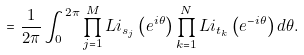<formula> <loc_0><loc_0><loc_500><loc_500>= \frac { 1 } { 2 \pi } \int _ { 0 } ^ { 2 \pi } \prod _ { j = 1 } ^ { M } L i _ { s _ { j } } \left ( e ^ { i \theta } \right ) \prod _ { k = 1 } ^ { N } L i _ { t _ { k } } \left ( e ^ { - i \theta } \right ) d \theta .</formula> 